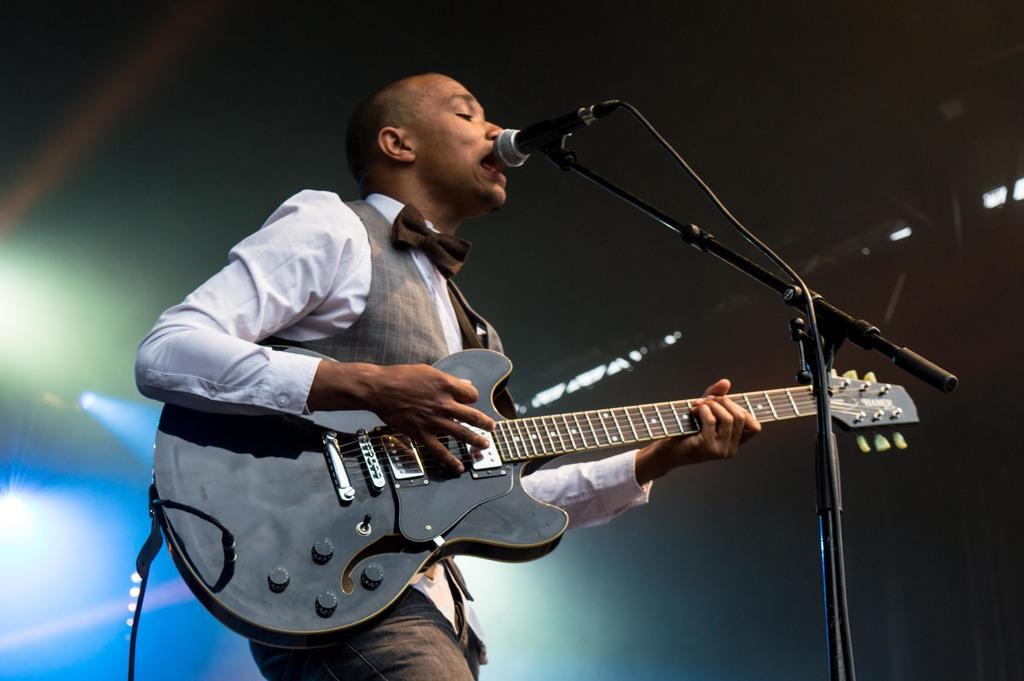What is the main subject of the image? The main subject of the image is a man. What is the man doing in the image? The man is standing, holding a guitar, and singing a song. What object is near the man? The man is near a microphone. What can be seen in the background of the image? There are flashlights and a ceiling visible in the background. What type of stone is the man using as a guide in the image? There is no stone or guide present in the image. The man is singing with a guitar near a microphone. 